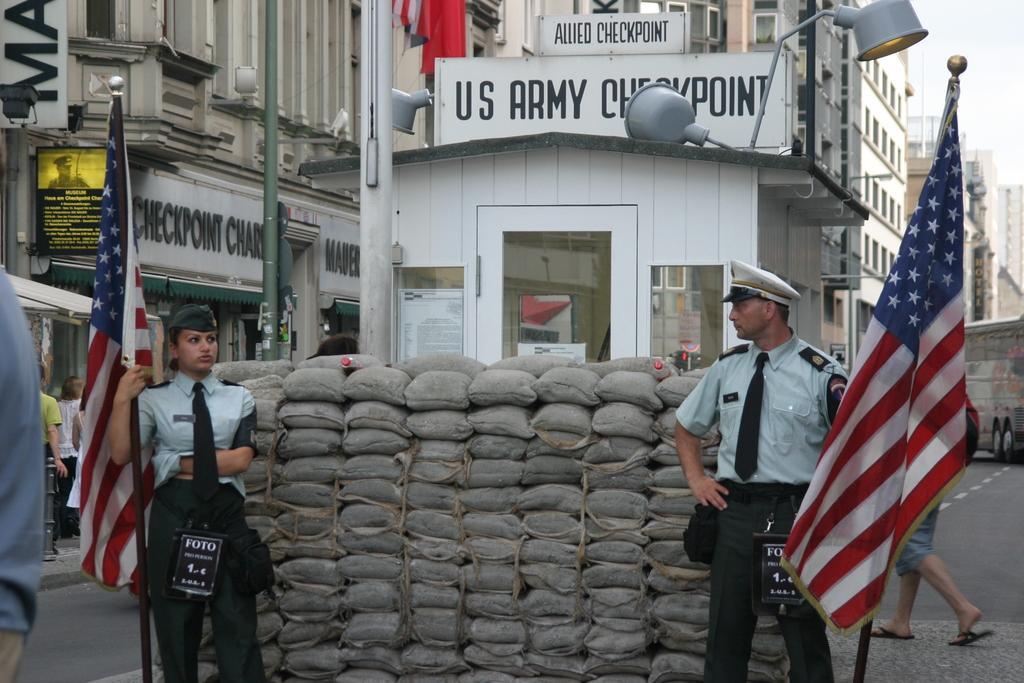Describe this image in one or two sentences. In this picture I can see buildings in the back and few boards with some text and couple of persons standing and holding flags in their hands and few are walking. I can see few bags and posters with some text on the glass and I can see a cloudy sky. 